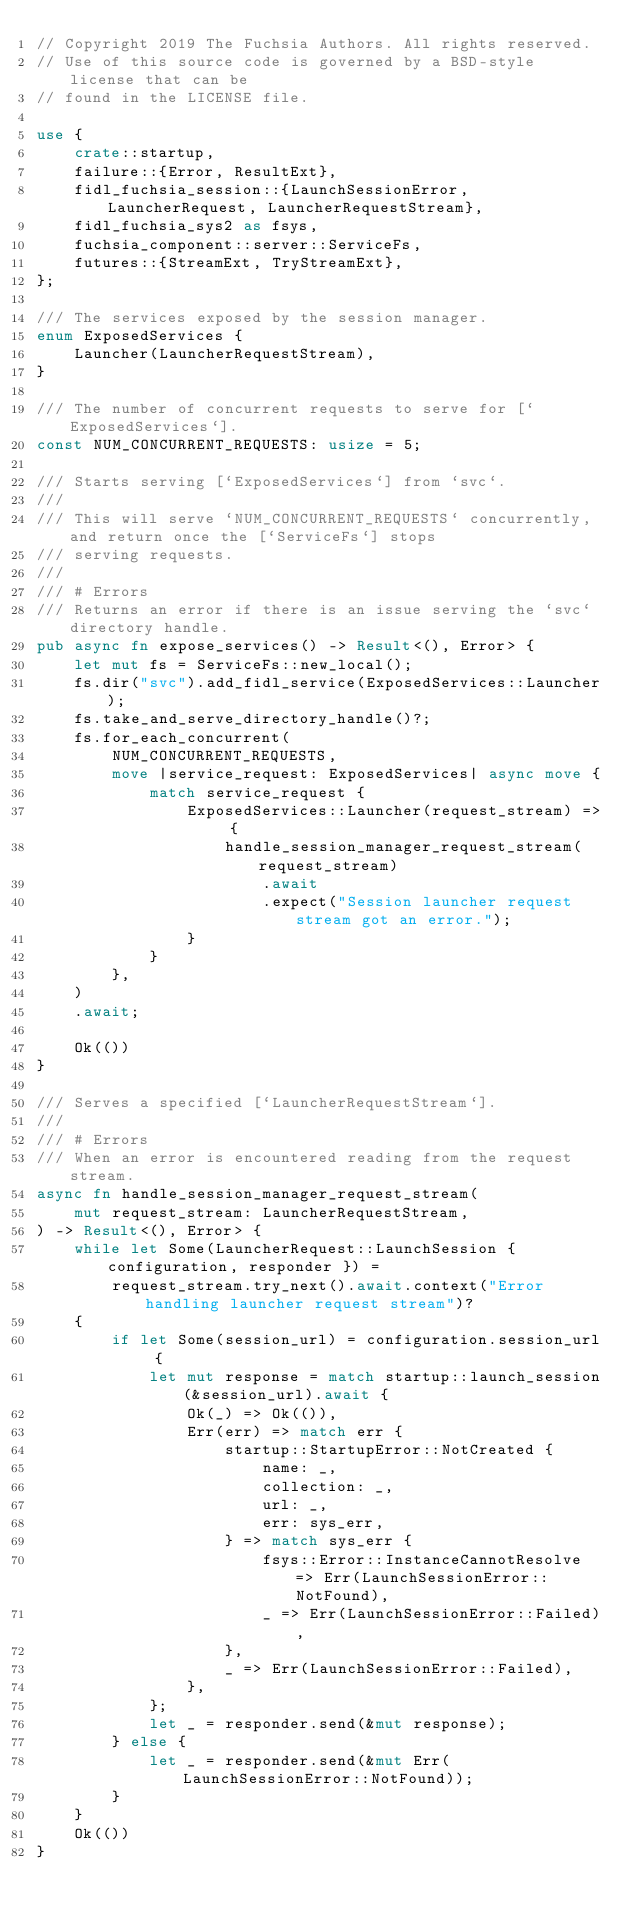<code> <loc_0><loc_0><loc_500><loc_500><_Rust_>// Copyright 2019 The Fuchsia Authors. All rights reserved.
// Use of this source code is governed by a BSD-style license that can be
// found in the LICENSE file.

use {
    crate::startup,
    failure::{Error, ResultExt},
    fidl_fuchsia_session::{LaunchSessionError, LauncherRequest, LauncherRequestStream},
    fidl_fuchsia_sys2 as fsys,
    fuchsia_component::server::ServiceFs,
    futures::{StreamExt, TryStreamExt},
};

/// The services exposed by the session manager.
enum ExposedServices {
    Launcher(LauncherRequestStream),
}

/// The number of concurrent requests to serve for [`ExposedServices`].
const NUM_CONCURRENT_REQUESTS: usize = 5;

/// Starts serving [`ExposedServices`] from `svc`.
///
/// This will serve `NUM_CONCURRENT_REQUESTS` concurrently, and return once the [`ServiceFs`] stops
/// serving requests.
///
/// # Errors
/// Returns an error if there is an issue serving the `svc` directory handle.
pub async fn expose_services() -> Result<(), Error> {
    let mut fs = ServiceFs::new_local();
    fs.dir("svc").add_fidl_service(ExposedServices::Launcher);
    fs.take_and_serve_directory_handle()?;
    fs.for_each_concurrent(
        NUM_CONCURRENT_REQUESTS,
        move |service_request: ExposedServices| async move {
            match service_request {
                ExposedServices::Launcher(request_stream) => {
                    handle_session_manager_request_stream(request_stream)
                        .await
                        .expect("Session launcher request stream got an error.");
                }
            }
        },
    )
    .await;

    Ok(())
}

/// Serves a specified [`LauncherRequestStream`].
///
/// # Errors
/// When an error is encountered reading from the request stream.
async fn handle_session_manager_request_stream(
    mut request_stream: LauncherRequestStream,
) -> Result<(), Error> {
    while let Some(LauncherRequest::LaunchSession { configuration, responder }) =
        request_stream.try_next().await.context("Error handling launcher request stream")?
    {
        if let Some(session_url) = configuration.session_url {
            let mut response = match startup::launch_session(&session_url).await {
                Ok(_) => Ok(()),
                Err(err) => match err {
                    startup::StartupError::NotCreated {
                        name: _,
                        collection: _,
                        url: _,
                        err: sys_err,
                    } => match sys_err {
                        fsys::Error::InstanceCannotResolve => Err(LaunchSessionError::NotFound),
                        _ => Err(LaunchSessionError::Failed),
                    },
                    _ => Err(LaunchSessionError::Failed),
                },
            };
            let _ = responder.send(&mut response);
        } else {
            let _ = responder.send(&mut Err(LaunchSessionError::NotFound));
        }
    }
    Ok(())
}
</code> 